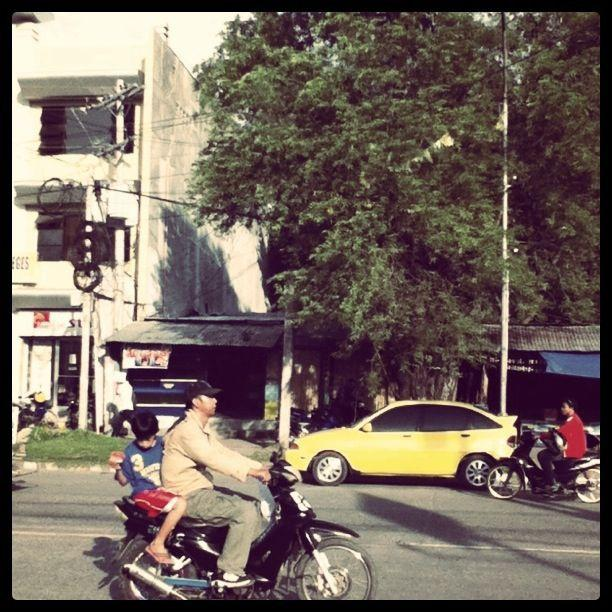Which mode of transportation shown here is most economical? motorcycle 